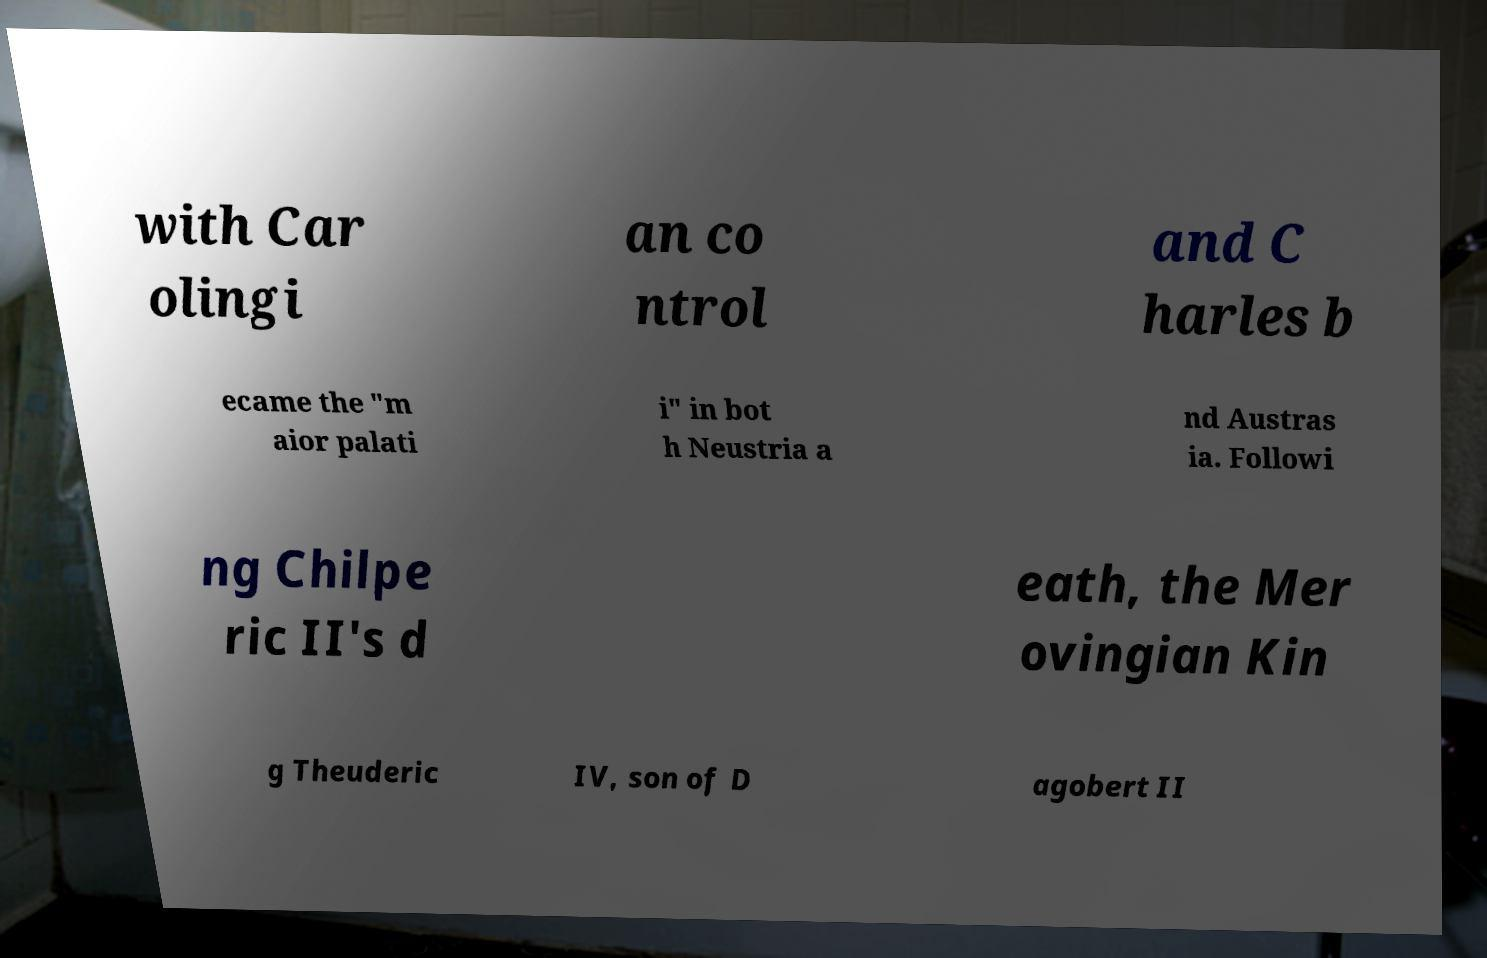What messages or text are displayed in this image? I need them in a readable, typed format. with Car olingi an co ntrol and C harles b ecame the "m aior palati i" in bot h Neustria a nd Austras ia. Followi ng Chilpe ric II's d eath, the Mer ovingian Kin g Theuderic IV, son of D agobert II 